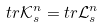<formula> <loc_0><loc_0><loc_500><loc_500>t r \mathcal { K } _ { s } ^ { n } = t r \mathcal { L } _ { s } ^ { n }</formula> 